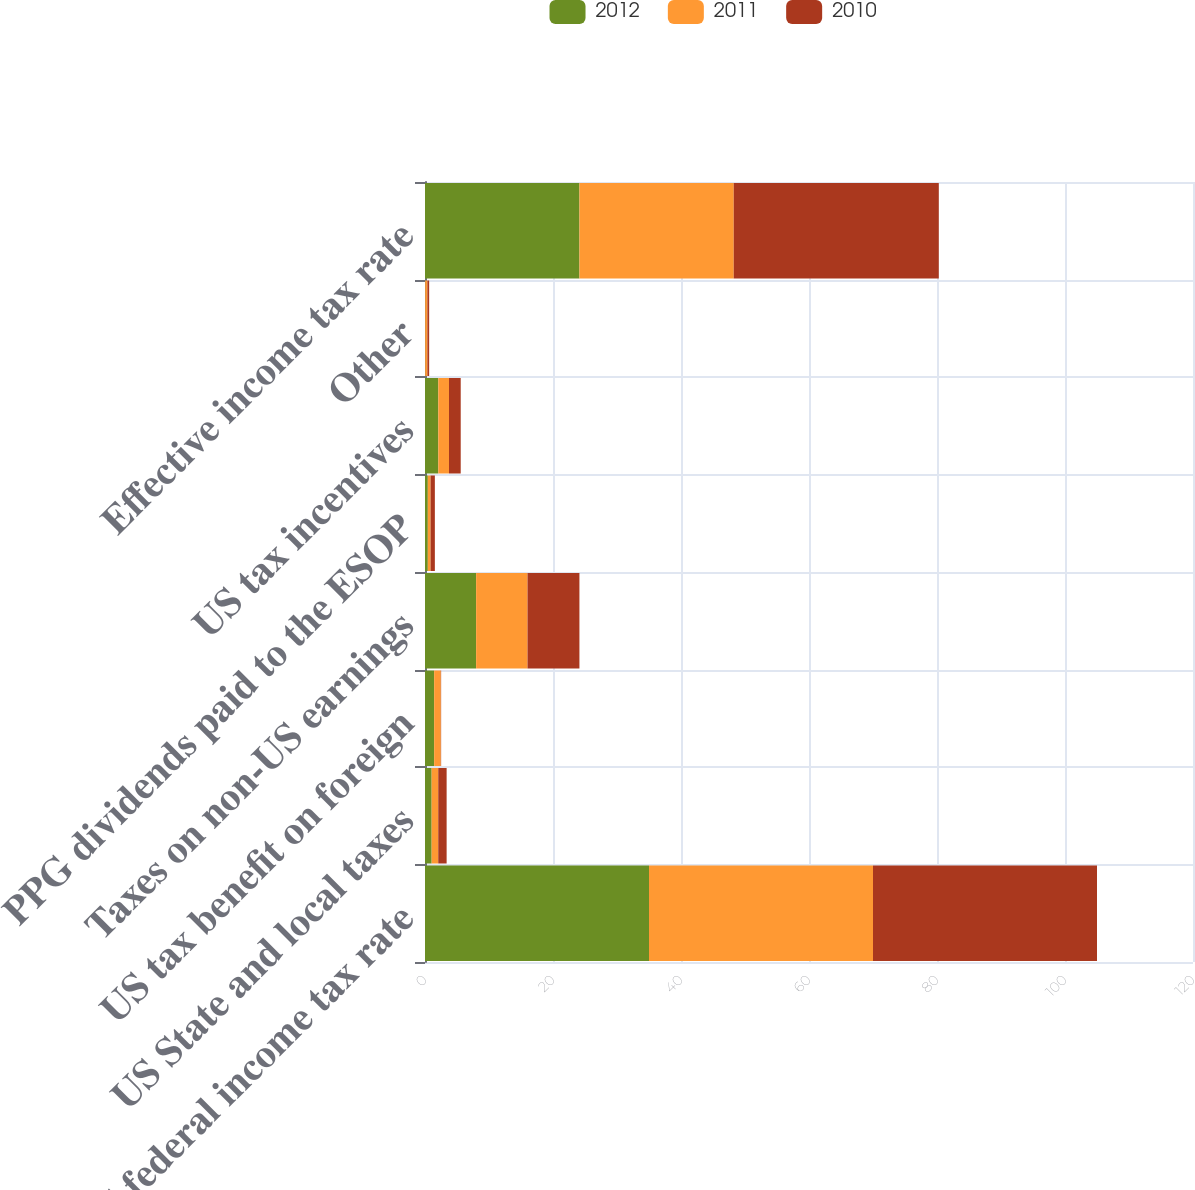Convert chart. <chart><loc_0><loc_0><loc_500><loc_500><stacked_bar_chart><ecel><fcel>US federal income tax rate<fcel>US State and local taxes<fcel>US tax benefit on foreign<fcel>Taxes on non-US earnings<fcel>PPG dividends paid to the ESOP<fcel>US tax incentives<fcel>Other<fcel>Effective income tax rate<nl><fcel>2012<fcel>35<fcel>1.04<fcel>1.43<fcel>7.99<fcel>0.44<fcel>2.08<fcel>0.03<fcel>24.13<nl><fcel>2011<fcel>35<fcel>1.03<fcel>1.04<fcel>8.03<fcel>0.43<fcel>1.67<fcel>0.34<fcel>24.11<nl><fcel>2010<fcel>35<fcel>1.31<fcel>0.05<fcel>8.11<fcel>0.67<fcel>1.83<fcel>0.28<fcel>32.04<nl></chart> 